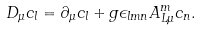Convert formula to latex. <formula><loc_0><loc_0><loc_500><loc_500>D _ { \mu } c _ { l } = \partial _ { \mu } c _ { l } + g \epsilon _ { l m n } A _ { L \mu } ^ { m } c _ { n } .</formula> 